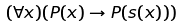<formula> <loc_0><loc_0><loc_500><loc_500>( \forall x ) ( P ( x ) \rightarrow P ( s ( x ) ) )</formula> 